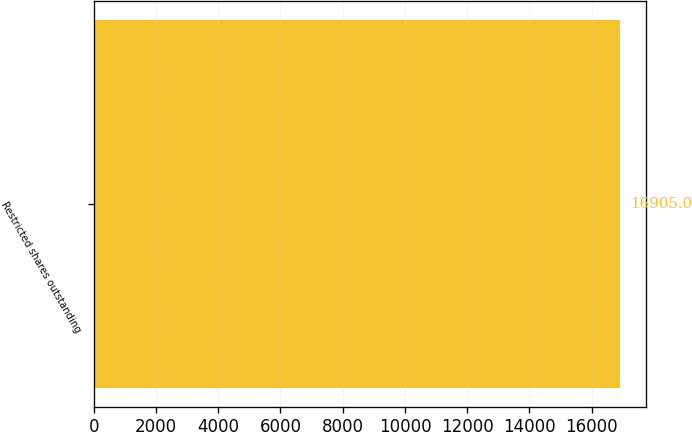Convert chart to OTSL. <chart><loc_0><loc_0><loc_500><loc_500><bar_chart><fcel>Restricted shares outstanding<nl><fcel>16905<nl></chart> 